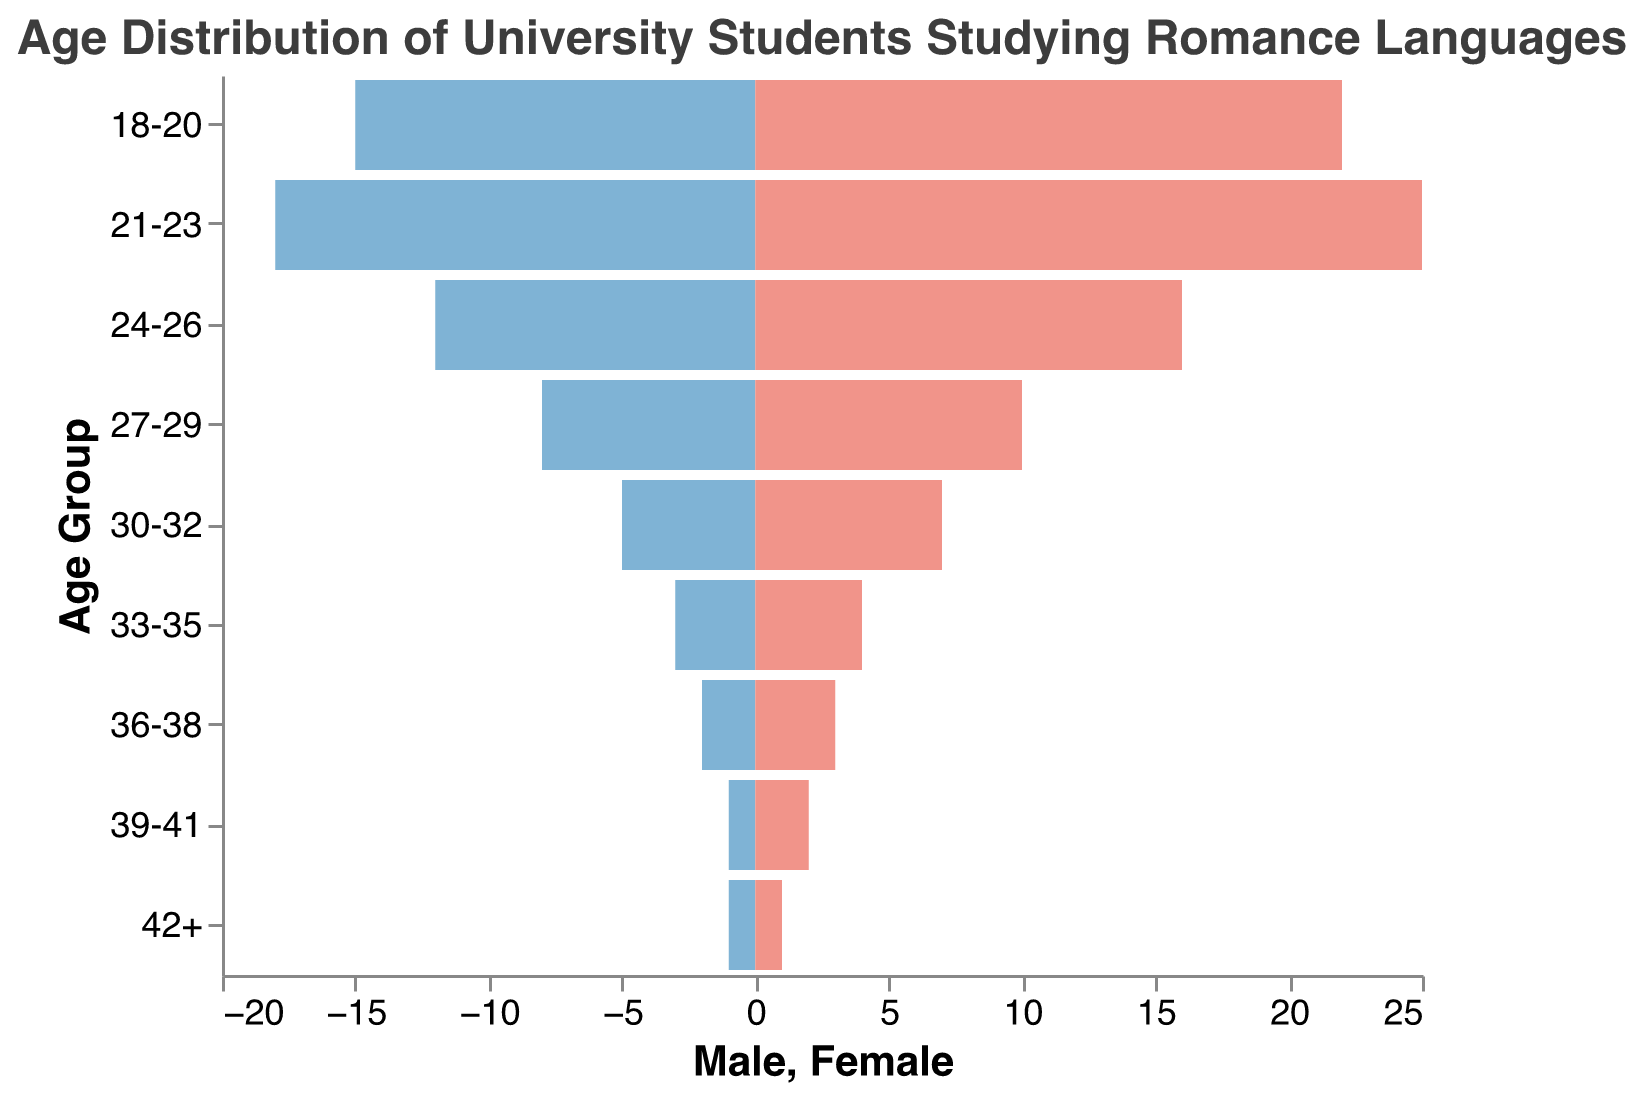Which age group has the highest number of female students? The age group with the highest number of female students can be identified by looking at the bars representing female students (colored in red) and finding the longest one. The age group 21-23 has the longest red bar representing 25 females.
Answer: 21-23 Which age group has the lowest number of male students? The age group with the lowest number of male students can be determined by finding the smallest blue bar. Looking at the negative values (since male values are negated), the age group 39-41 and 42+ each have 1 male student, making them the lowest.
Answer: 39-41 or 42+ What is the difference in the number of male and female students in the age group 30-32? Find the values for males and females in the 30-32 age group. For this group, there are 5 males and 7 females. The difference is calculated by subtracting the number of males from the number of females (7 - 5).
Answer: 2 How many more female students are there than male students in the age group 21-23? The number of female students in the 21-23 age group is 25 and the number of male students is 18. Subtract the number of males from the number of females (25 - 18).
Answer: 7 What is the total number of students in the age group 24-26? Add the number of male and female students in the age group 24-26. There are 12 males and 16 females, so the total is (12 + 16).
Answer: 28 Which age group shows the closest balance between male and female students? To find the closest balance, we need to look at the groups where the difference between the number of male and female students is the smallest. The age group 42+ has 1 male and 1 female student, so the difference is 0.
Answer: 42+ Which age group has the highest total number of students? To find the age group with the highest total number of students, add the male and female students for each age group. The age group 21-23 has the highest total with (18 + 25) = 43 students.
Answer: 21-23 What is the average number of female students across all age groups? Add the number of female students across all age groups: 22 + 25 + 16 + 10 + 7 + 4 + 3 + 2 + 1 = 90. There are 9 age groups, so divide the total by 9 (90 / 9).
Answer: 10 How many more female students are there compared to male students in total? Sum the total number of male students and female students across all age groups. Males: 15 + 18 + 12 + 8 + 5 + 3 + 2 + 1 + 1 = 65. Females: 22 + 25 + 16 + 10 + 7 + 4 + 3 + 2 + 1 = 90. Subtract the total number of males from the total number of females (90 - 65).
Answer: 25 